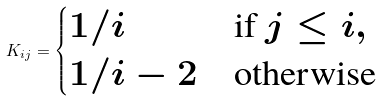<formula> <loc_0><loc_0><loc_500><loc_500>K _ { i j } = \begin{cases} 1 / i & \text {if $j\leq i$} , \\ 1 / i - 2 & \text {otherwise} \end{cases}</formula> 